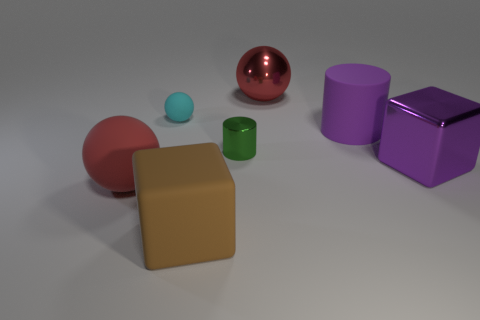Does the green object that is behind the brown matte block have the same size as the small cyan ball?
Your answer should be compact. Yes. Are there any small objects that have the same color as the big cylinder?
Offer a terse response. No. What number of objects are large brown rubber blocks in front of the green cylinder or large balls left of the tiny rubber thing?
Offer a terse response. 2. Is the tiny cylinder the same color as the rubber cube?
Provide a short and direct response. No. What material is the big cylinder that is the same color as the large metallic cube?
Your response must be concise. Rubber. Are there fewer large things that are to the left of the big purple shiny block than big brown rubber objects to the left of the large brown thing?
Your answer should be very brief. No. Are the large brown thing and the tiny cyan sphere made of the same material?
Make the answer very short. Yes. There is a ball that is both behind the small green metallic thing and on the left side of the tiny metallic thing; what size is it?
Offer a very short reply. Small. There is a purple metallic thing that is the same size as the brown object; what shape is it?
Your response must be concise. Cube. There is a red ball in front of the block that is behind the red ball left of the cyan rubber thing; what is it made of?
Offer a very short reply. Rubber. 